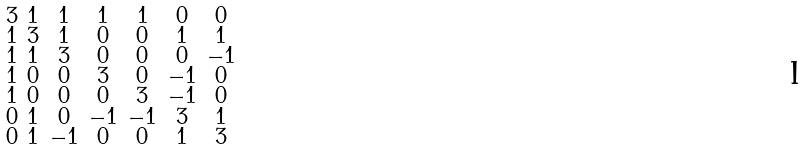<formula> <loc_0><loc_0><loc_500><loc_500>\begin{smallmatrix} 3 & 1 & 1 & 1 & 1 & 0 & 0 \\ 1 & 3 & 1 & 0 & 0 & 1 & 1 \\ 1 & 1 & 3 & 0 & 0 & 0 & - 1 \\ 1 & 0 & 0 & 3 & 0 & - 1 & 0 \\ 1 & 0 & 0 & 0 & 3 & - 1 & 0 \\ 0 & 1 & 0 & - 1 & - 1 & 3 & 1 \\ 0 & 1 & - 1 & 0 & 0 & 1 & 3 \end{smallmatrix}</formula> 